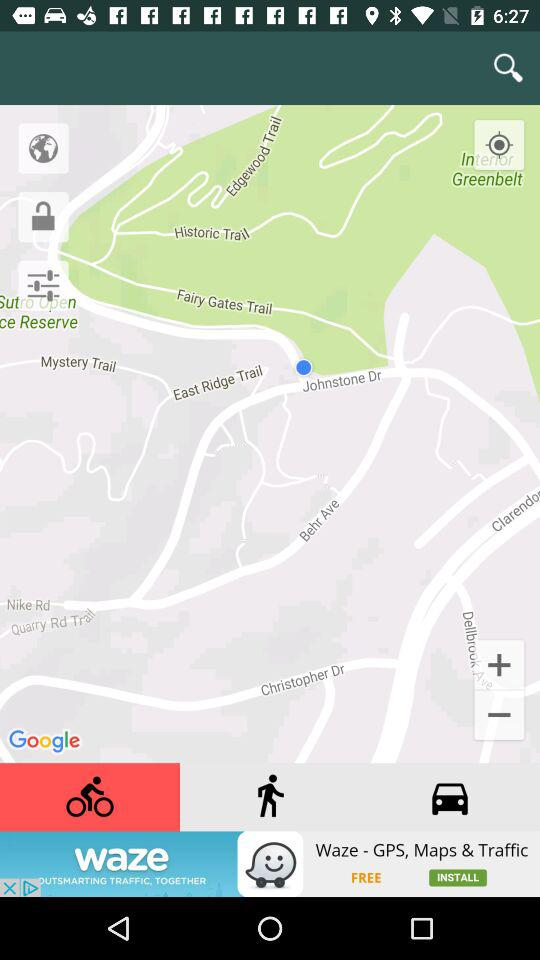What has a value of 4.616? 4.616 is the value of location accuracy. 